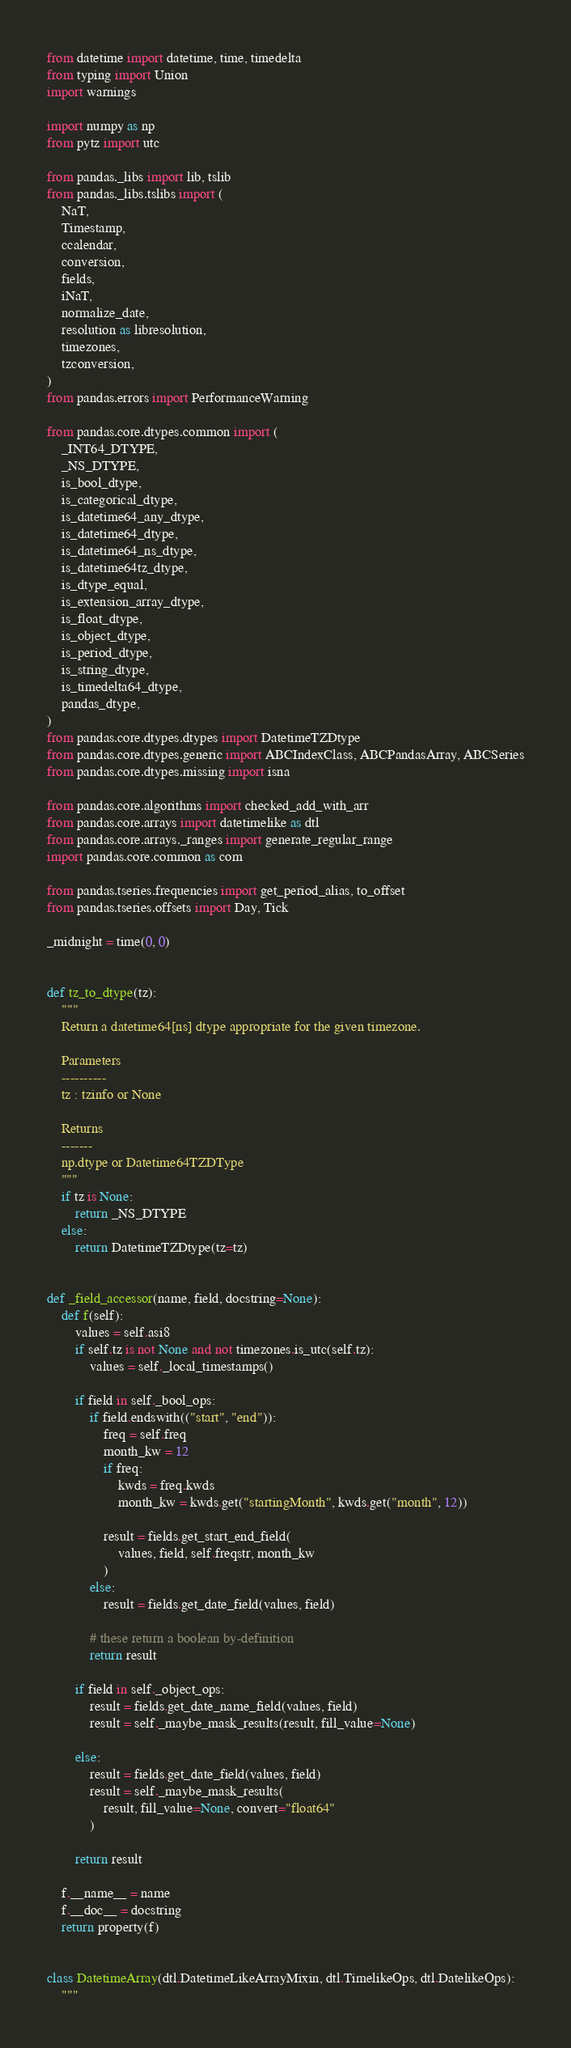Convert code to text. <code><loc_0><loc_0><loc_500><loc_500><_Python_>from datetime import datetime, time, timedelta
from typing import Union
import warnings

import numpy as np
from pytz import utc

from pandas._libs import lib, tslib
from pandas._libs.tslibs import (
    NaT,
    Timestamp,
    ccalendar,
    conversion,
    fields,
    iNaT,
    normalize_date,
    resolution as libresolution,
    timezones,
    tzconversion,
)
from pandas.errors import PerformanceWarning

from pandas.core.dtypes.common import (
    _INT64_DTYPE,
    _NS_DTYPE,
    is_bool_dtype,
    is_categorical_dtype,
    is_datetime64_any_dtype,
    is_datetime64_dtype,
    is_datetime64_ns_dtype,
    is_datetime64tz_dtype,
    is_dtype_equal,
    is_extension_array_dtype,
    is_float_dtype,
    is_object_dtype,
    is_period_dtype,
    is_string_dtype,
    is_timedelta64_dtype,
    pandas_dtype,
)
from pandas.core.dtypes.dtypes import DatetimeTZDtype
from pandas.core.dtypes.generic import ABCIndexClass, ABCPandasArray, ABCSeries
from pandas.core.dtypes.missing import isna

from pandas.core.algorithms import checked_add_with_arr
from pandas.core.arrays import datetimelike as dtl
from pandas.core.arrays._ranges import generate_regular_range
import pandas.core.common as com

from pandas.tseries.frequencies import get_period_alias, to_offset
from pandas.tseries.offsets import Day, Tick

_midnight = time(0, 0)


def tz_to_dtype(tz):
    """
    Return a datetime64[ns] dtype appropriate for the given timezone.

    Parameters
    ----------
    tz : tzinfo or None

    Returns
    -------
    np.dtype or Datetime64TZDType
    """
    if tz is None:
        return _NS_DTYPE
    else:
        return DatetimeTZDtype(tz=tz)


def _field_accessor(name, field, docstring=None):
    def f(self):
        values = self.asi8
        if self.tz is not None and not timezones.is_utc(self.tz):
            values = self._local_timestamps()

        if field in self._bool_ops:
            if field.endswith(("start", "end")):
                freq = self.freq
                month_kw = 12
                if freq:
                    kwds = freq.kwds
                    month_kw = kwds.get("startingMonth", kwds.get("month", 12))

                result = fields.get_start_end_field(
                    values, field, self.freqstr, month_kw
                )
            else:
                result = fields.get_date_field(values, field)

            # these return a boolean by-definition
            return result

        if field in self._object_ops:
            result = fields.get_date_name_field(values, field)
            result = self._maybe_mask_results(result, fill_value=None)

        else:
            result = fields.get_date_field(values, field)
            result = self._maybe_mask_results(
                result, fill_value=None, convert="float64"
            )

        return result

    f.__name__ = name
    f.__doc__ = docstring
    return property(f)


class DatetimeArray(dtl.DatetimeLikeArrayMixin, dtl.TimelikeOps, dtl.DatelikeOps):
    """</code> 